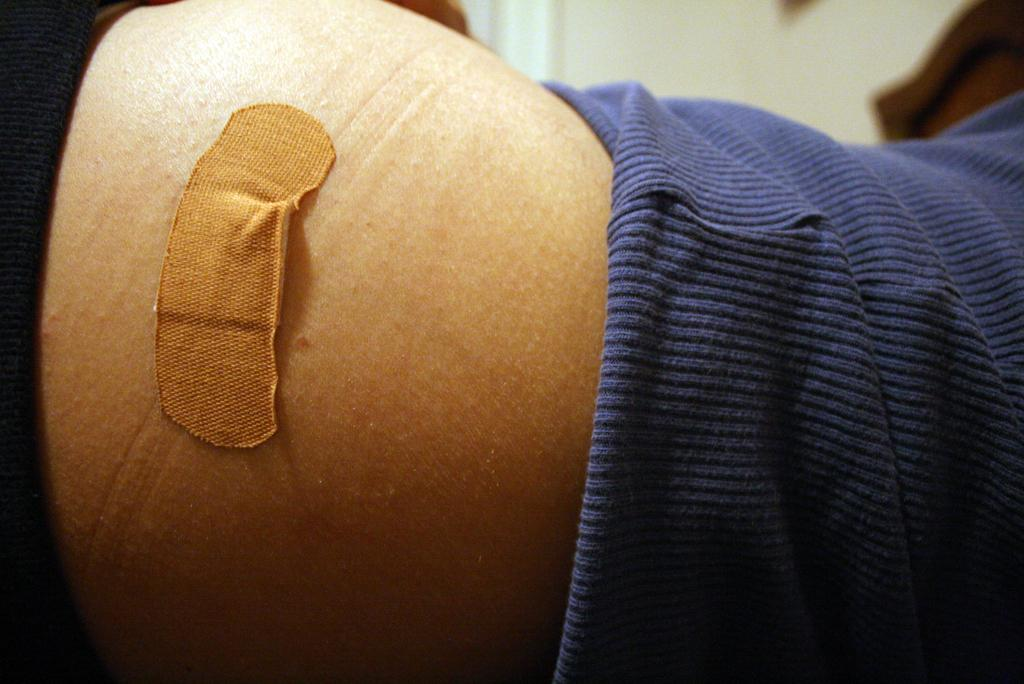What is visible on the body of the person in the image? There is a first aid plaster on the body of a person in the image. What type of hook is the servant using on the ship in the image? There is no hook, servant, or ship present in the image. 